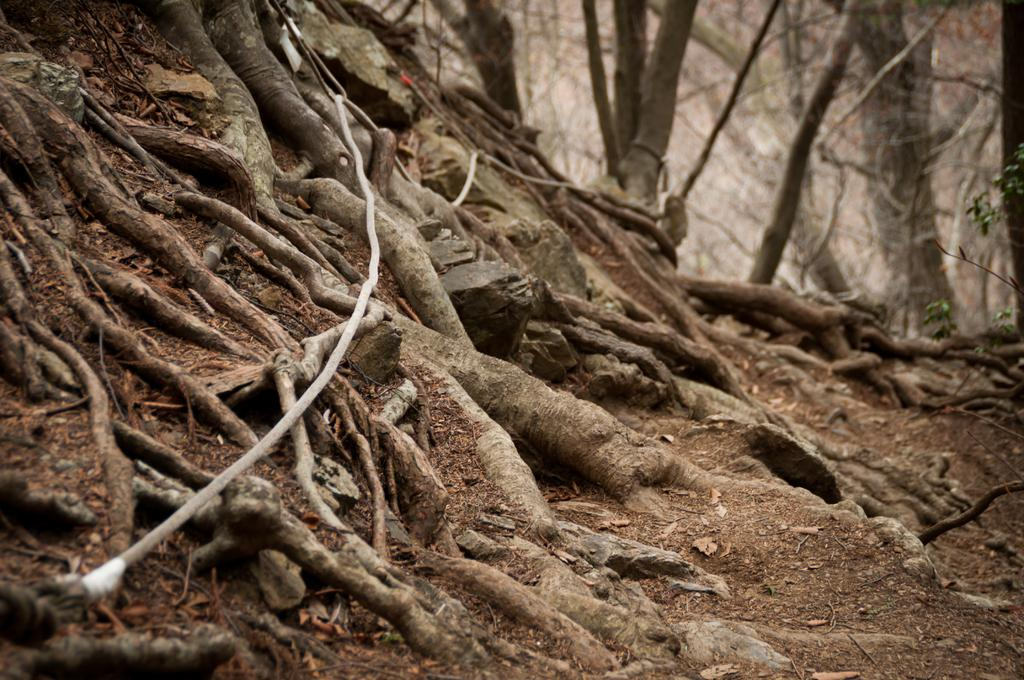What type of natural vegetation can be seen in the image? There are trees in the image. What color is the object that stands out in the image? There is a white object in the image. What type of terrain is visible in the image? There is mud visible in the image. What type of match can be seen in the image? There is no match present in the image. What type of work is being done in the image? There is no indication of any work being done in the image. 